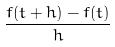Convert formula to latex. <formula><loc_0><loc_0><loc_500><loc_500>\frac { f ( t + h ) - f ( t ) } { h }</formula> 